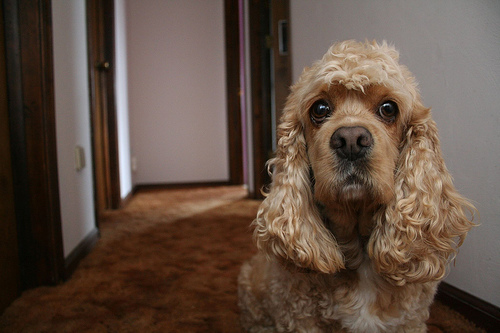<image>
Is the wall behind the puppy? Yes. From this viewpoint, the wall is positioned behind the puppy, with the puppy partially or fully occluding the wall. 